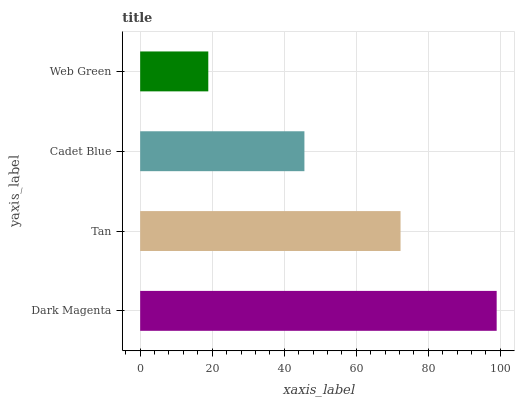Is Web Green the minimum?
Answer yes or no. Yes. Is Dark Magenta the maximum?
Answer yes or no. Yes. Is Tan the minimum?
Answer yes or no. No. Is Tan the maximum?
Answer yes or no. No. Is Dark Magenta greater than Tan?
Answer yes or no. Yes. Is Tan less than Dark Magenta?
Answer yes or no. Yes. Is Tan greater than Dark Magenta?
Answer yes or no. No. Is Dark Magenta less than Tan?
Answer yes or no. No. Is Tan the high median?
Answer yes or no. Yes. Is Cadet Blue the low median?
Answer yes or no. Yes. Is Cadet Blue the high median?
Answer yes or no. No. Is Dark Magenta the low median?
Answer yes or no. No. 